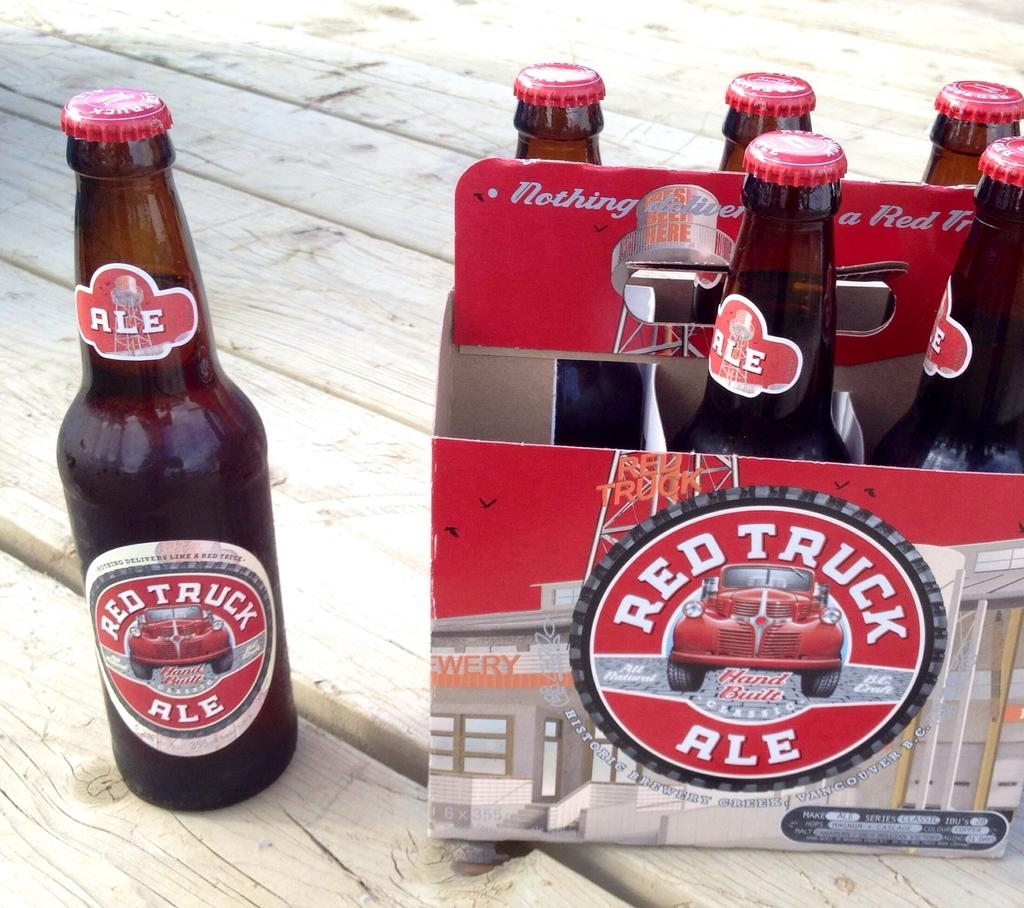What objects can be seen in the image? There is a bottle and a box in the image. Can you describe the bottle in the image? The facts provided do not give any specific details about the bottle, so we cannot describe it further. What can you tell me about the box in the image? The facts provided do not give any specific details about the box, so we cannot describe it further. How many babies are present in the image? There are no babies present in the image; it only contains a bottle and a box. What family members can be seen interacting with the idea in the image? There is no reference to a family or an idea in the image, so we cannot answer this question. 